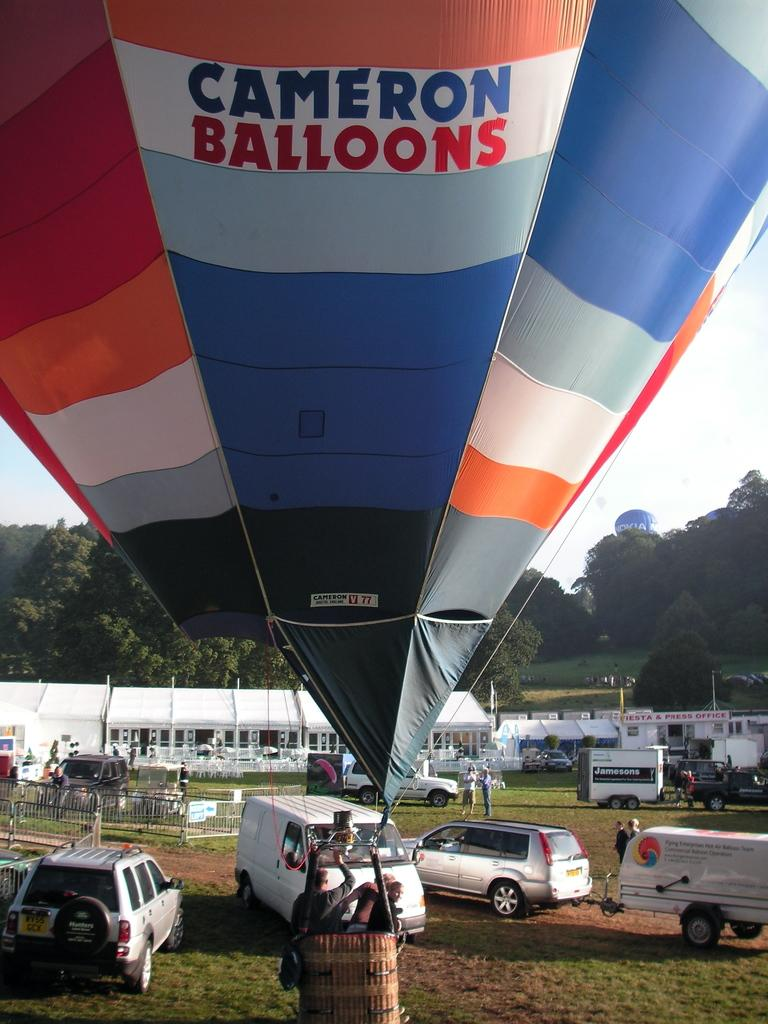<image>
Write a terse but informative summary of the picture. The hot air balloon is from Cameron Balloons. 